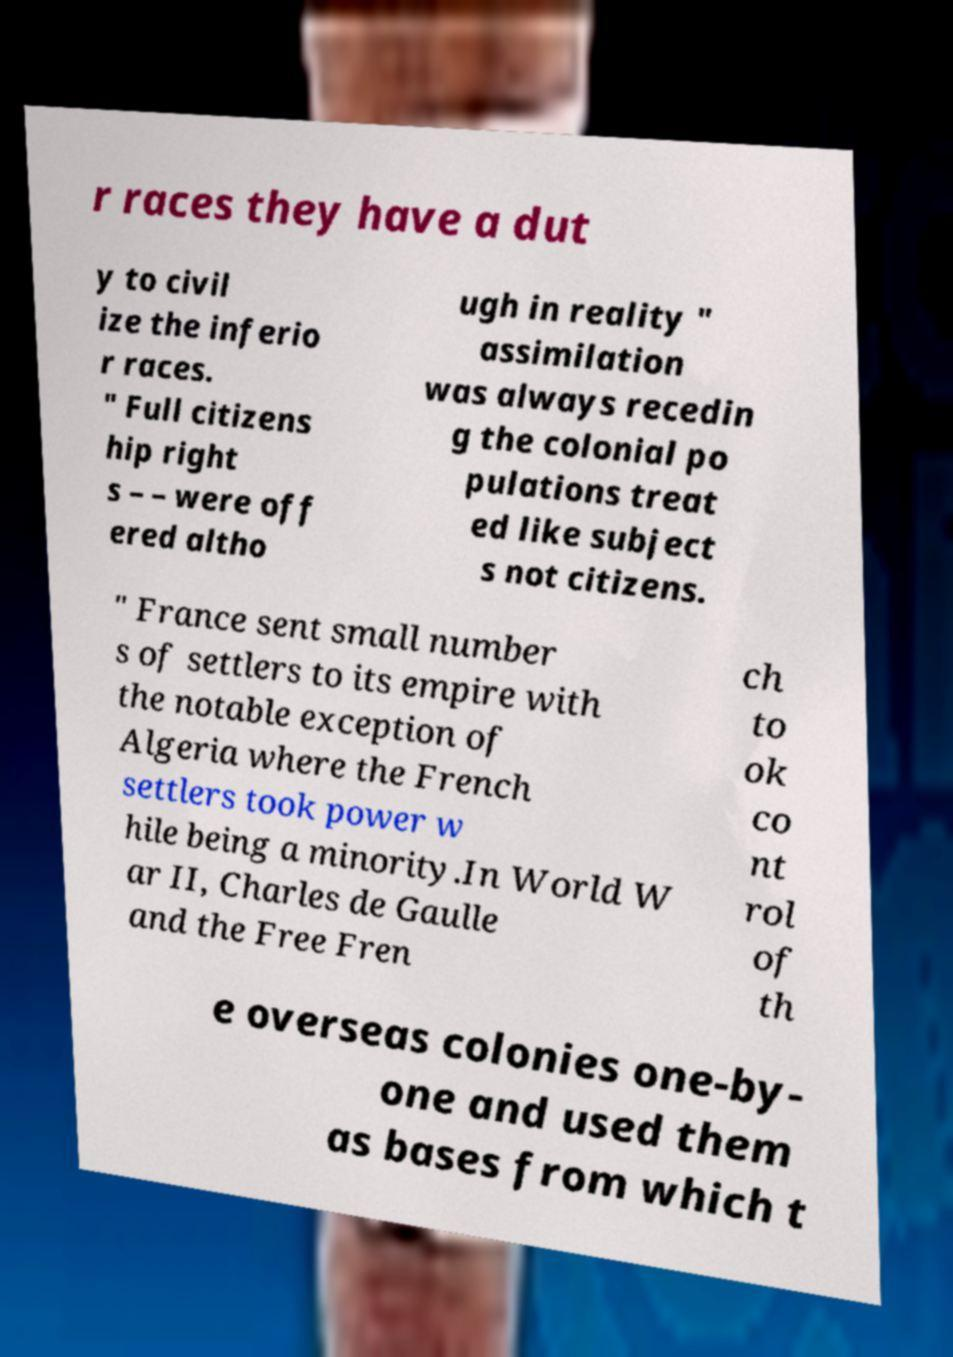Could you assist in decoding the text presented in this image and type it out clearly? r races they have a dut y to civil ize the inferio r races. " Full citizens hip right s – – were off ered altho ugh in reality " assimilation was always recedin g the colonial po pulations treat ed like subject s not citizens. " France sent small number s of settlers to its empire with the notable exception of Algeria where the French settlers took power w hile being a minority.In World W ar II, Charles de Gaulle and the Free Fren ch to ok co nt rol of th e overseas colonies one-by- one and used them as bases from which t 